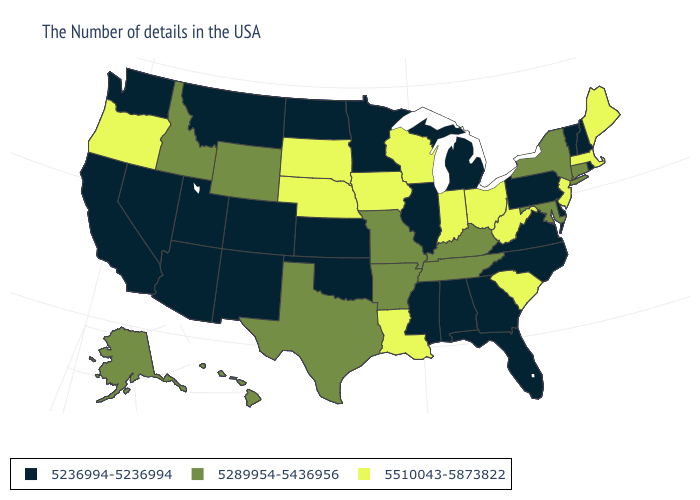Name the states that have a value in the range 5236994-5236994?
Concise answer only. Rhode Island, New Hampshire, Vermont, Delaware, Pennsylvania, Virginia, North Carolina, Florida, Georgia, Michigan, Alabama, Illinois, Mississippi, Minnesota, Kansas, Oklahoma, North Dakota, Colorado, New Mexico, Utah, Montana, Arizona, Nevada, California, Washington. Does the first symbol in the legend represent the smallest category?
Concise answer only. Yes. What is the lowest value in the West?
Concise answer only. 5236994-5236994. Name the states that have a value in the range 5289954-5436956?
Give a very brief answer. Connecticut, New York, Maryland, Kentucky, Tennessee, Missouri, Arkansas, Texas, Wyoming, Idaho, Alaska, Hawaii. What is the highest value in the USA?
Give a very brief answer. 5510043-5873822. What is the value of Rhode Island?
Concise answer only. 5236994-5236994. What is the highest value in states that border West Virginia?
Write a very short answer. 5510043-5873822. Name the states that have a value in the range 5236994-5236994?
Quick response, please. Rhode Island, New Hampshire, Vermont, Delaware, Pennsylvania, Virginia, North Carolina, Florida, Georgia, Michigan, Alabama, Illinois, Mississippi, Minnesota, Kansas, Oklahoma, North Dakota, Colorado, New Mexico, Utah, Montana, Arizona, Nevada, California, Washington. Does South Carolina have a higher value than Connecticut?
Keep it brief. Yes. Does Nebraska have the highest value in the USA?
Concise answer only. Yes. What is the value of Tennessee?
Keep it brief. 5289954-5436956. What is the value of Maine?
Answer briefly. 5510043-5873822. Which states have the highest value in the USA?
Be succinct. Maine, Massachusetts, New Jersey, South Carolina, West Virginia, Ohio, Indiana, Wisconsin, Louisiana, Iowa, Nebraska, South Dakota, Oregon. Which states have the lowest value in the USA?
Quick response, please. Rhode Island, New Hampshire, Vermont, Delaware, Pennsylvania, Virginia, North Carolina, Florida, Georgia, Michigan, Alabama, Illinois, Mississippi, Minnesota, Kansas, Oklahoma, North Dakota, Colorado, New Mexico, Utah, Montana, Arizona, Nevada, California, Washington. What is the value of Oregon?
Give a very brief answer. 5510043-5873822. 